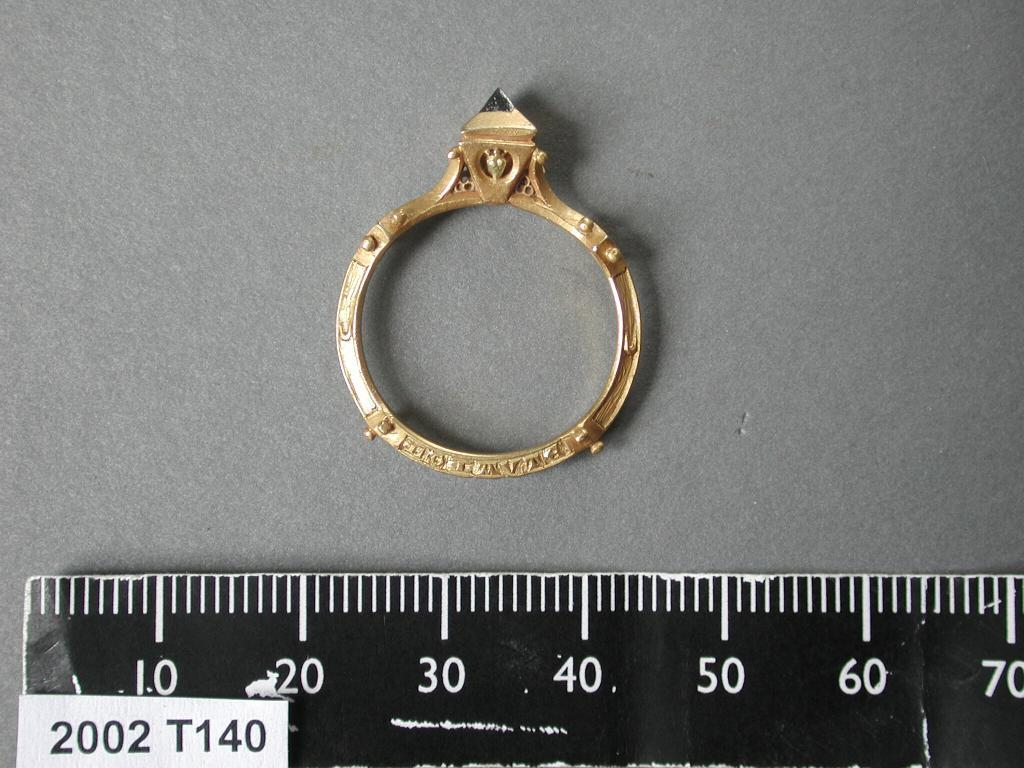<image>
Relay a brief, clear account of the picture shown. A ruler with a "2002 T140" tag on it. 